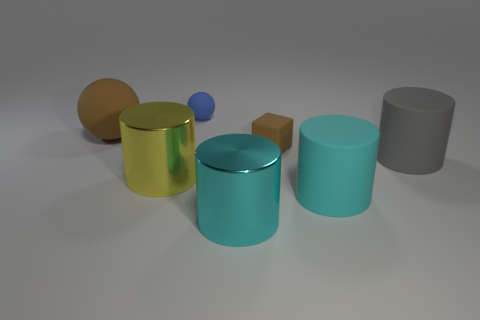Is there a brown object that is to the right of the large shiny cylinder in front of the large yellow object?
Provide a short and direct response. Yes. Is the yellow object the same shape as the cyan metal thing?
Your answer should be very brief. Yes. There is a big cyan object that is made of the same material as the blue sphere; what shape is it?
Give a very brief answer. Cylinder. There is a blue sphere that is behind the big brown matte thing; does it have the same size as the yellow object that is in front of the gray rubber cylinder?
Provide a succinct answer. No. Is the number of things that are in front of the large matte sphere greater than the number of yellow cylinders left of the big yellow metallic cylinder?
Offer a terse response. Yes. How many other objects are the same color as the small rubber cube?
Ensure brevity in your answer.  1. Does the block have the same color as the small matte thing that is behind the small brown rubber cube?
Offer a terse response. No. How many big gray cylinders are to the left of the rubber cylinder left of the large gray rubber thing?
Your answer should be very brief. 0. Are there any other things that are the same material as the tiny brown object?
Ensure brevity in your answer.  Yes. What material is the brown thing that is to the right of the large cyan cylinder that is to the left of the big matte cylinder in front of the yellow thing made of?
Give a very brief answer. Rubber. 